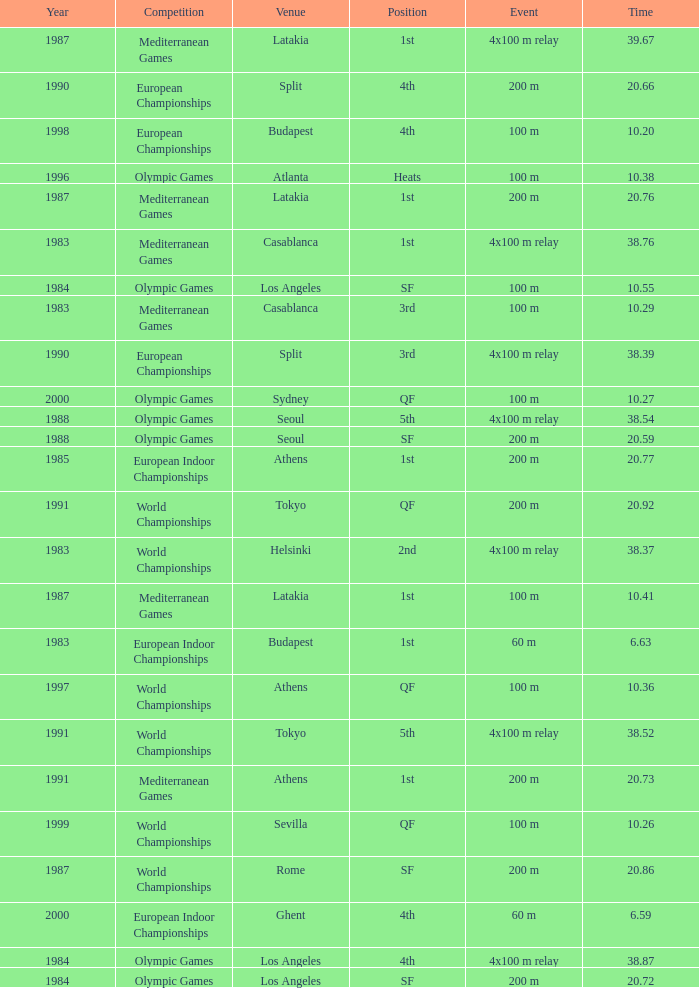What Event has a Position of 1st, a Year of 1983, and a Venue of budapest? 60 m. 